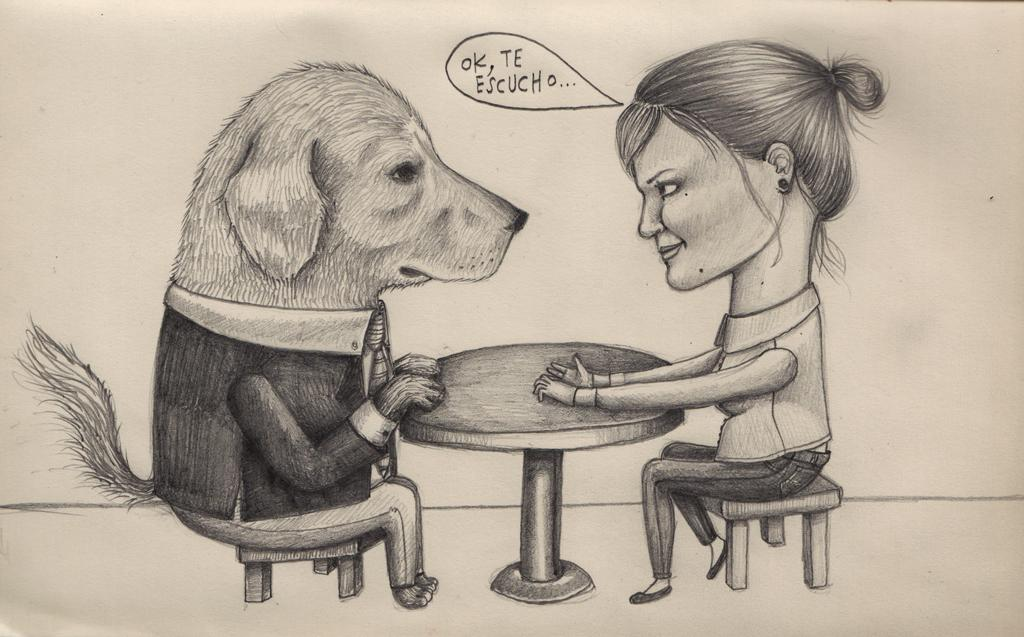What is the main subject of the sketch in the image? The main subject of the sketch in the image is a dog. What is the dog doing in the sketch? The sketch of a dog is sitting on a stool. Are there any other characters in the sketch? Yes, there is a woman in the sketch. What is the woman doing in the sketch? The woman is sitting on a stool. What other objects are present in the sketch? There is a table in the sketch. Is there any text visible in the image? Yes, there is writing visible in the image. What type of acoustics can be heard in the image? There is no sound or acoustics present in the image, as it is a sketch of a dog and a woman sitting on stools. What advice does the father give to the woman in the image? There is no father or any dialogue present in the image, as it is a sketch of a dog and a woman sitting on stools. 